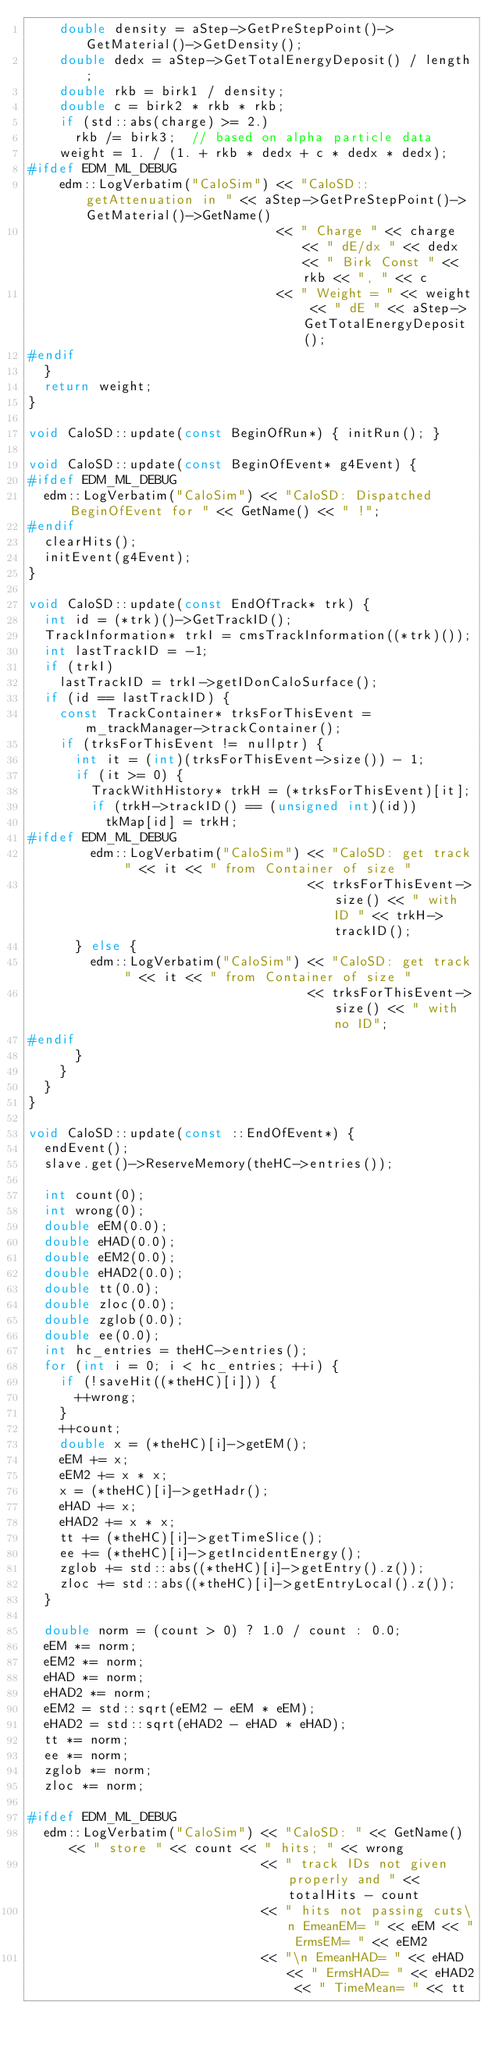<code> <loc_0><loc_0><loc_500><loc_500><_C++_>    double density = aStep->GetPreStepPoint()->GetMaterial()->GetDensity();
    double dedx = aStep->GetTotalEnergyDeposit() / length;
    double rkb = birk1 / density;
    double c = birk2 * rkb * rkb;
    if (std::abs(charge) >= 2.)
      rkb /= birk3;  // based on alpha particle data
    weight = 1. / (1. + rkb * dedx + c * dedx * dedx);
#ifdef EDM_ML_DEBUG
    edm::LogVerbatim("CaloSim") << "CaloSD::getAttenuation in " << aStep->GetPreStepPoint()->GetMaterial()->GetName()
                                << " Charge " << charge << " dE/dx " << dedx << " Birk Const " << rkb << ", " << c
                                << " Weight = " << weight << " dE " << aStep->GetTotalEnergyDeposit();
#endif
  }
  return weight;
}

void CaloSD::update(const BeginOfRun*) { initRun(); }

void CaloSD::update(const BeginOfEvent* g4Event) {
#ifdef EDM_ML_DEBUG
  edm::LogVerbatim("CaloSim") << "CaloSD: Dispatched BeginOfEvent for " << GetName() << " !";
#endif
  clearHits();
  initEvent(g4Event);
}

void CaloSD::update(const EndOfTrack* trk) {
  int id = (*trk)()->GetTrackID();
  TrackInformation* trkI = cmsTrackInformation((*trk)());
  int lastTrackID = -1;
  if (trkI)
    lastTrackID = trkI->getIDonCaloSurface();
  if (id == lastTrackID) {
    const TrackContainer* trksForThisEvent = m_trackManager->trackContainer();
    if (trksForThisEvent != nullptr) {
      int it = (int)(trksForThisEvent->size()) - 1;
      if (it >= 0) {
        TrackWithHistory* trkH = (*trksForThisEvent)[it];
        if (trkH->trackID() == (unsigned int)(id))
          tkMap[id] = trkH;
#ifdef EDM_ML_DEBUG
        edm::LogVerbatim("CaloSim") << "CaloSD: get track " << it << " from Container of size "
                                    << trksForThisEvent->size() << " with ID " << trkH->trackID();
      } else {
        edm::LogVerbatim("CaloSim") << "CaloSD: get track " << it << " from Container of size "
                                    << trksForThisEvent->size() << " with no ID";
#endif
      }
    }
  }
}

void CaloSD::update(const ::EndOfEvent*) {
  endEvent();
  slave.get()->ReserveMemory(theHC->entries());

  int count(0);
  int wrong(0);
  double eEM(0.0);
  double eHAD(0.0);
  double eEM2(0.0);
  double eHAD2(0.0);
  double tt(0.0);
  double zloc(0.0);
  double zglob(0.0);
  double ee(0.0);
  int hc_entries = theHC->entries();
  for (int i = 0; i < hc_entries; ++i) {
    if (!saveHit((*theHC)[i])) {
      ++wrong;
    }
    ++count;
    double x = (*theHC)[i]->getEM();
    eEM += x;
    eEM2 += x * x;
    x = (*theHC)[i]->getHadr();
    eHAD += x;
    eHAD2 += x * x;
    tt += (*theHC)[i]->getTimeSlice();
    ee += (*theHC)[i]->getIncidentEnergy();
    zglob += std::abs((*theHC)[i]->getEntry().z());
    zloc += std::abs((*theHC)[i]->getEntryLocal().z());
  }

  double norm = (count > 0) ? 1.0 / count : 0.0;
  eEM *= norm;
  eEM2 *= norm;
  eHAD *= norm;
  eHAD2 *= norm;
  eEM2 = std::sqrt(eEM2 - eEM * eEM);
  eHAD2 = std::sqrt(eHAD2 - eHAD * eHAD);
  tt *= norm;
  ee *= norm;
  zglob *= norm;
  zloc *= norm;

#ifdef EDM_ML_DEBUG
  edm::LogVerbatim("CaloSim") << "CaloSD: " << GetName() << " store " << count << " hits; " << wrong
                              << " track IDs not given properly and " << totalHits - count
                              << " hits not passing cuts\n EmeanEM= " << eEM << " ErmsEM= " << eEM2
                              << "\n EmeanHAD= " << eHAD << " ErmsHAD= " << eHAD2 << " TimeMean= " << tt</code> 